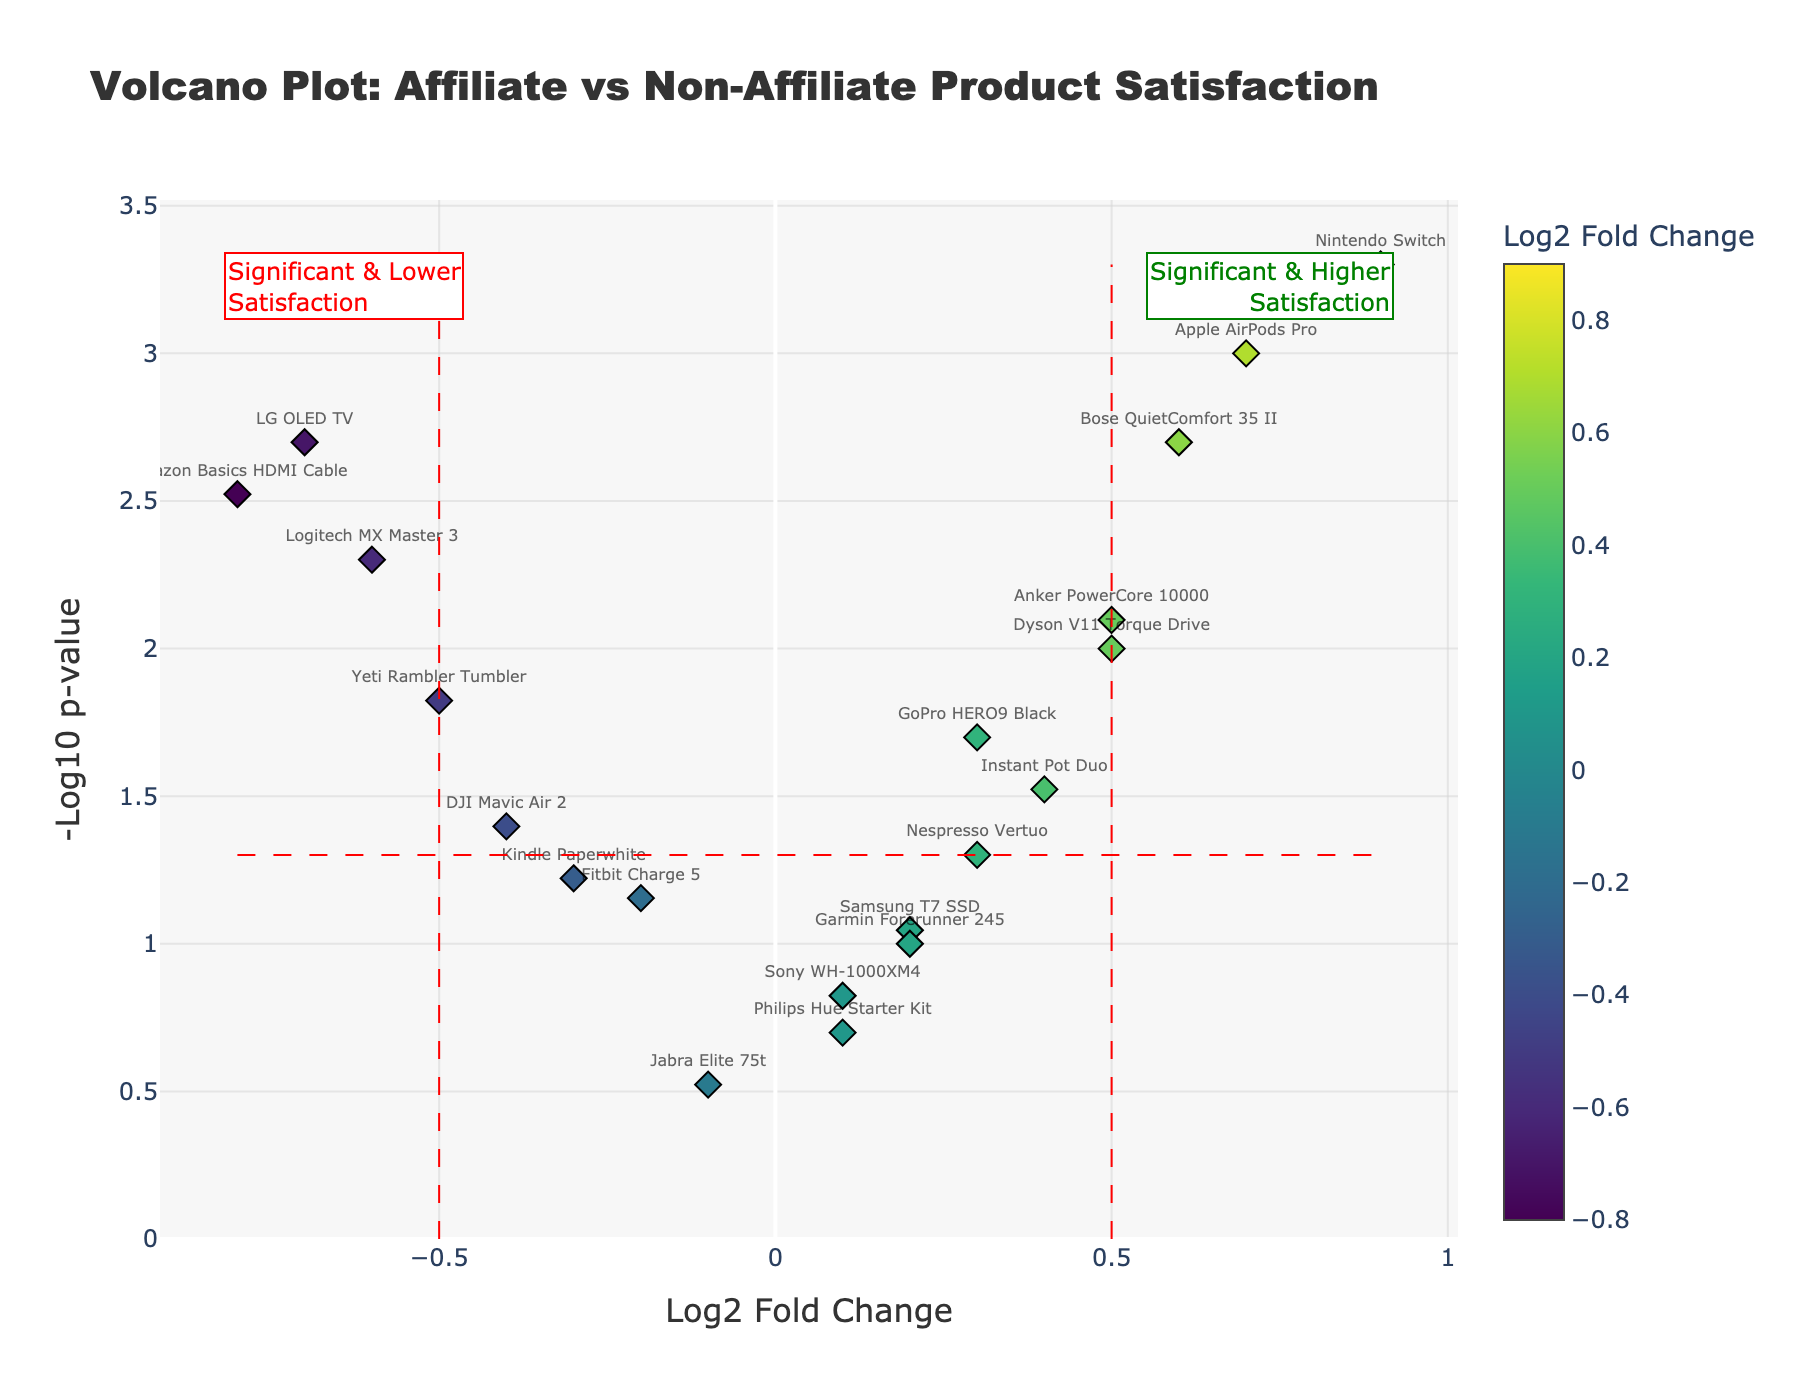What is the title of the figure? The title is written at the top of the figure and is clearly labeled.
Answer: Volcano Plot: Affiliate vs Non-Affiliate Product Satisfaction How many products are plotted in the figure? Count each marker representing a product in the volcano plot.
Answer: 20 Which product has the highest customer satisfaction score? Look for the product with the highest positive log2 fold change and the lowest p-value. This marker will be in the top right quadrant and furthest to the right.
Answer: Nintendo Switch Which product has the lowest customer satisfaction score? Look for the product with the lowest negative log2 fold change and the lowest p-value. This marker will be in the top left quadrant and furthest to the left.
Answer: Amazon Basics HDMI Cable How many products have a log2 fold change greater than 0.5? Count the markers that are positioned to the right of the vertical line at 0.5 on the x-axis.
Answer: 3 What does a log2 fold change threshold of 0.5 indicate in this plot? The vertical red dashed line at 0.5 signifies products with substantial positive changes in customer satisfaction scores, suggesting a noticeable preference.
Answer: Significant positive change Which products lie within the significant region but have lower satisfaction? Identify products below the horizontal red dashed line (indicating significant p-values) and to the left of the vertical line at -0.5 on the x-axis.
Answer: Amazon Basics HDMI Cable, Logitech MX Master 3, LG OLED TV Calculate the average log2 fold change of the products plotted. Sum all the log2 fold change values and divide by the total number of products: (-0.8 + 0.3 + 0.1 + 0.5 - 0.2 + 0.7 + 0.4 - 0.6 + 0.2 + 0.6 - 0.3 + 0.1 - 0.4 + 0.9 - 0.1 + 0.5 + 0.3 - 0.7 + 0.2 - 0.5) / 20 = 0.02
Answer: 0.02 Are there more products with higher or lower customer satisfaction scores? Count the number of markers to the right of zero (higher satisfaction) and to the left of zero (lower satisfaction) on the x-axis.
Answer: Higher satisfaction Which product has the least significant p-value, yet positive satisfaction? Identify the marker with the smallest value on the y-axis (nearest the origin) but with a positive log2 fold change value on the x-axis.
Answer: Philips Hue Starter Kit 